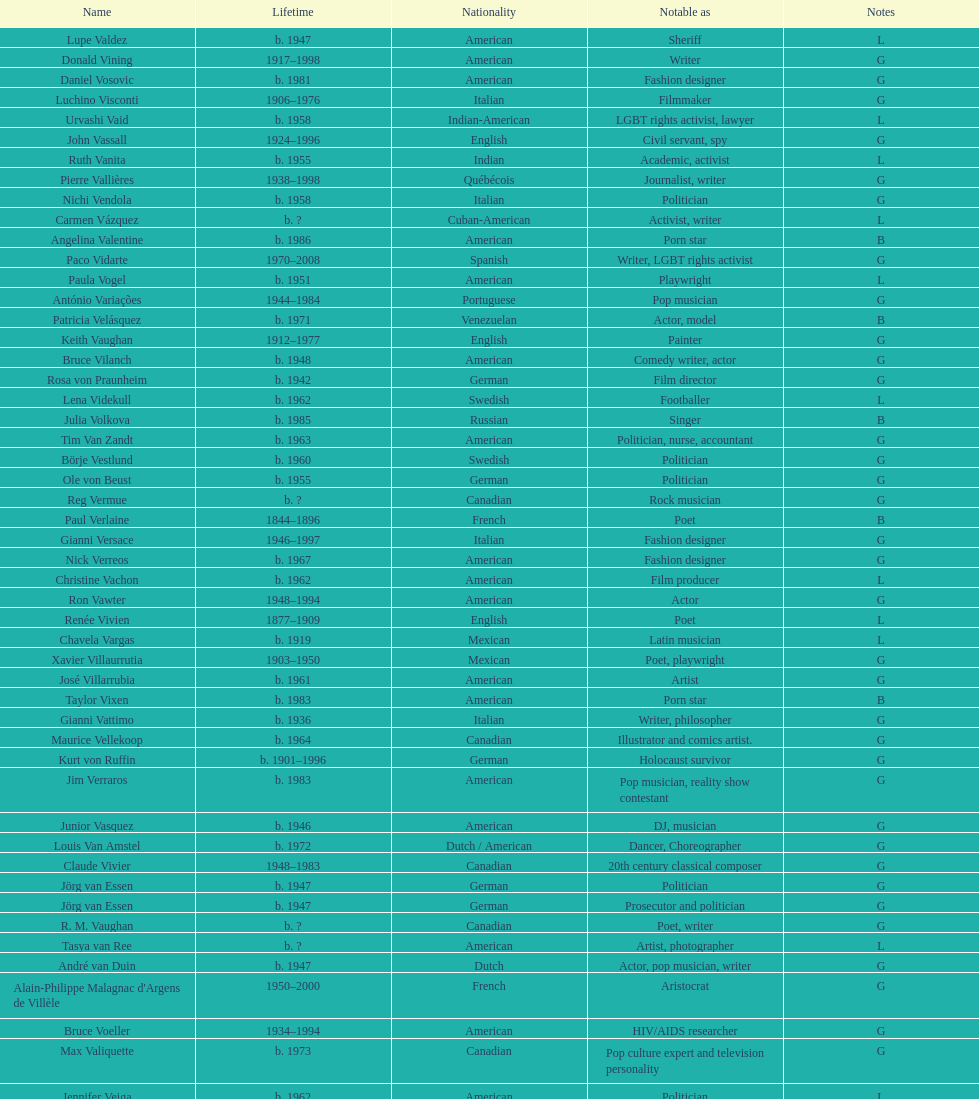Which nationality had the most notable poets? French. 